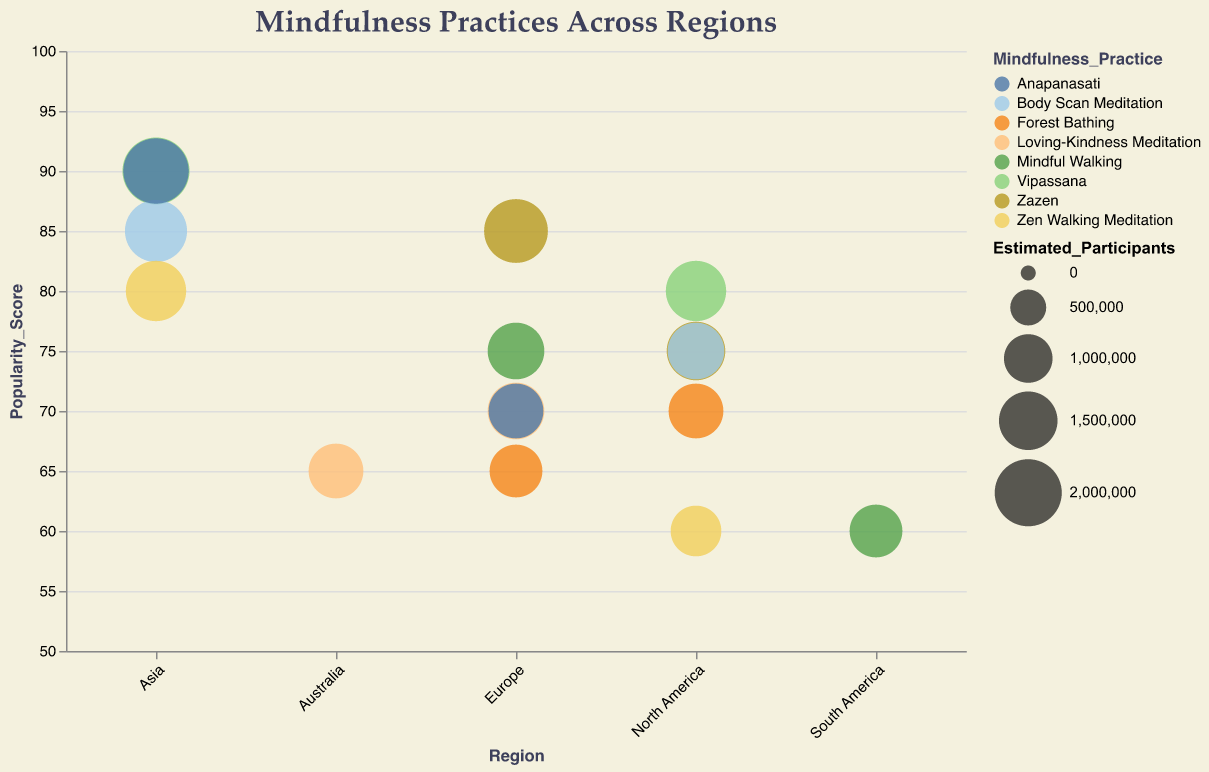what is the title of the figure? The title of the figure is clearly written at the top of the chart. It provides a summary of what the chart is about.
Answer: Mindfulness Practices Across Regions Which variety of meditation is the most popular in Asia based on the popularity score? By looking at the "Popularity_Score" on the vertical axis for all mindfulness practices in the Asia region, "Vipassana" and "Anapanasati" both have the highest popularity score of 90.
Answer: Vipassana, Anapanasati Which region practices "Mindful Walking" the least? Compare the estimated participants for "Mindful Walking" across different regions by looking at the size of bubbles. South America has the smallest bubble for "Mindful Walking".
Answer: South America How many mindfulness practices have a popularity score of 75 in "North America"? Count the number of bubbles in the "North America" region which have a "Popularity_Score" of 75. There are two bubbles meeting this criteria, one for "Zazen" and one for "Body Scan Meditation".
Answer: 2 What's the estimated number of participants for "Zazen" in Europe? Look at the size of the bubble for "Zazen" in Europe and refer to the tooltip to find the estimated participants. It shows "1800000".
Answer: 1800000 Is “Vipassana” more popular in Asia or North America? Compare the size of the bubbles and the popularity scores for "Vipassana" in both regions. Asia has a bubble with a popularity score of 90, while North America has a score of 80.
Answer: Asia Compare the popularity score of "Forest Bathing" in Europe and North America. Which region scores higher? By comparing the "Forest Bathing" bubbles in both regions, look at the "Popularity_Score". Europe has a score of 65, while North America scores 70.
Answer: North America Which mindfulness practice has the highest estimated participants in North America? Compare all the bubbles in the North America region and identify the one with the largest size. "Vipassana" has the largest bubble indicating the highest estimated participants.
Answer: Vipassana Which region sees the highest popularity score for "Body Scan Meditation"? Compare the "Popularity_Score" for "Body Scan Meditation" in different regions by looking at the vertical positioning of the bubbles. Asia has a popularity score of 85, which is higher than North America's 75.
Answer: Asia How many regions are represented in the chart? Count the unique labels on the horizontal axis to determine the number of regions shown in the chart. There are five regions: North America, Europe, Asia, South America, Australia.
Answer: 5 